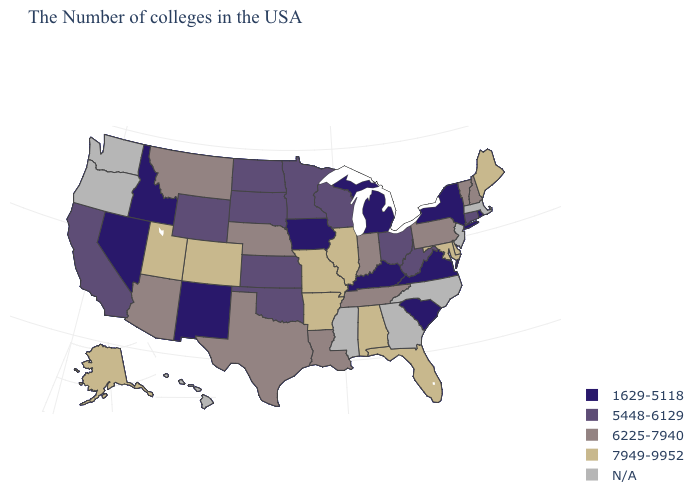Name the states that have a value in the range 1629-5118?
Keep it brief. Rhode Island, New York, Virginia, South Carolina, Michigan, Kentucky, Iowa, New Mexico, Idaho, Nevada. What is the value of Nevada?
Keep it brief. 1629-5118. Which states have the lowest value in the USA?
Write a very short answer. Rhode Island, New York, Virginia, South Carolina, Michigan, Kentucky, Iowa, New Mexico, Idaho, Nevada. Does the first symbol in the legend represent the smallest category?
Keep it brief. Yes. Among the states that border New Hampshire , which have the lowest value?
Answer briefly. Vermont. Name the states that have a value in the range 7949-9952?
Short answer required. Maine, Delaware, Maryland, Florida, Alabama, Illinois, Missouri, Arkansas, Colorado, Utah, Alaska. Does the map have missing data?
Keep it brief. Yes. Name the states that have a value in the range 5448-6129?
Write a very short answer. Connecticut, West Virginia, Ohio, Wisconsin, Minnesota, Kansas, Oklahoma, South Dakota, North Dakota, Wyoming, California. What is the value of Colorado?
Keep it brief. 7949-9952. What is the value of Alaska?
Short answer required. 7949-9952. What is the highest value in states that border Iowa?
Concise answer only. 7949-9952. Which states hav the highest value in the West?
Concise answer only. Colorado, Utah, Alaska. What is the value of Florida?
Give a very brief answer. 7949-9952. What is the value of North Carolina?
Concise answer only. N/A. 